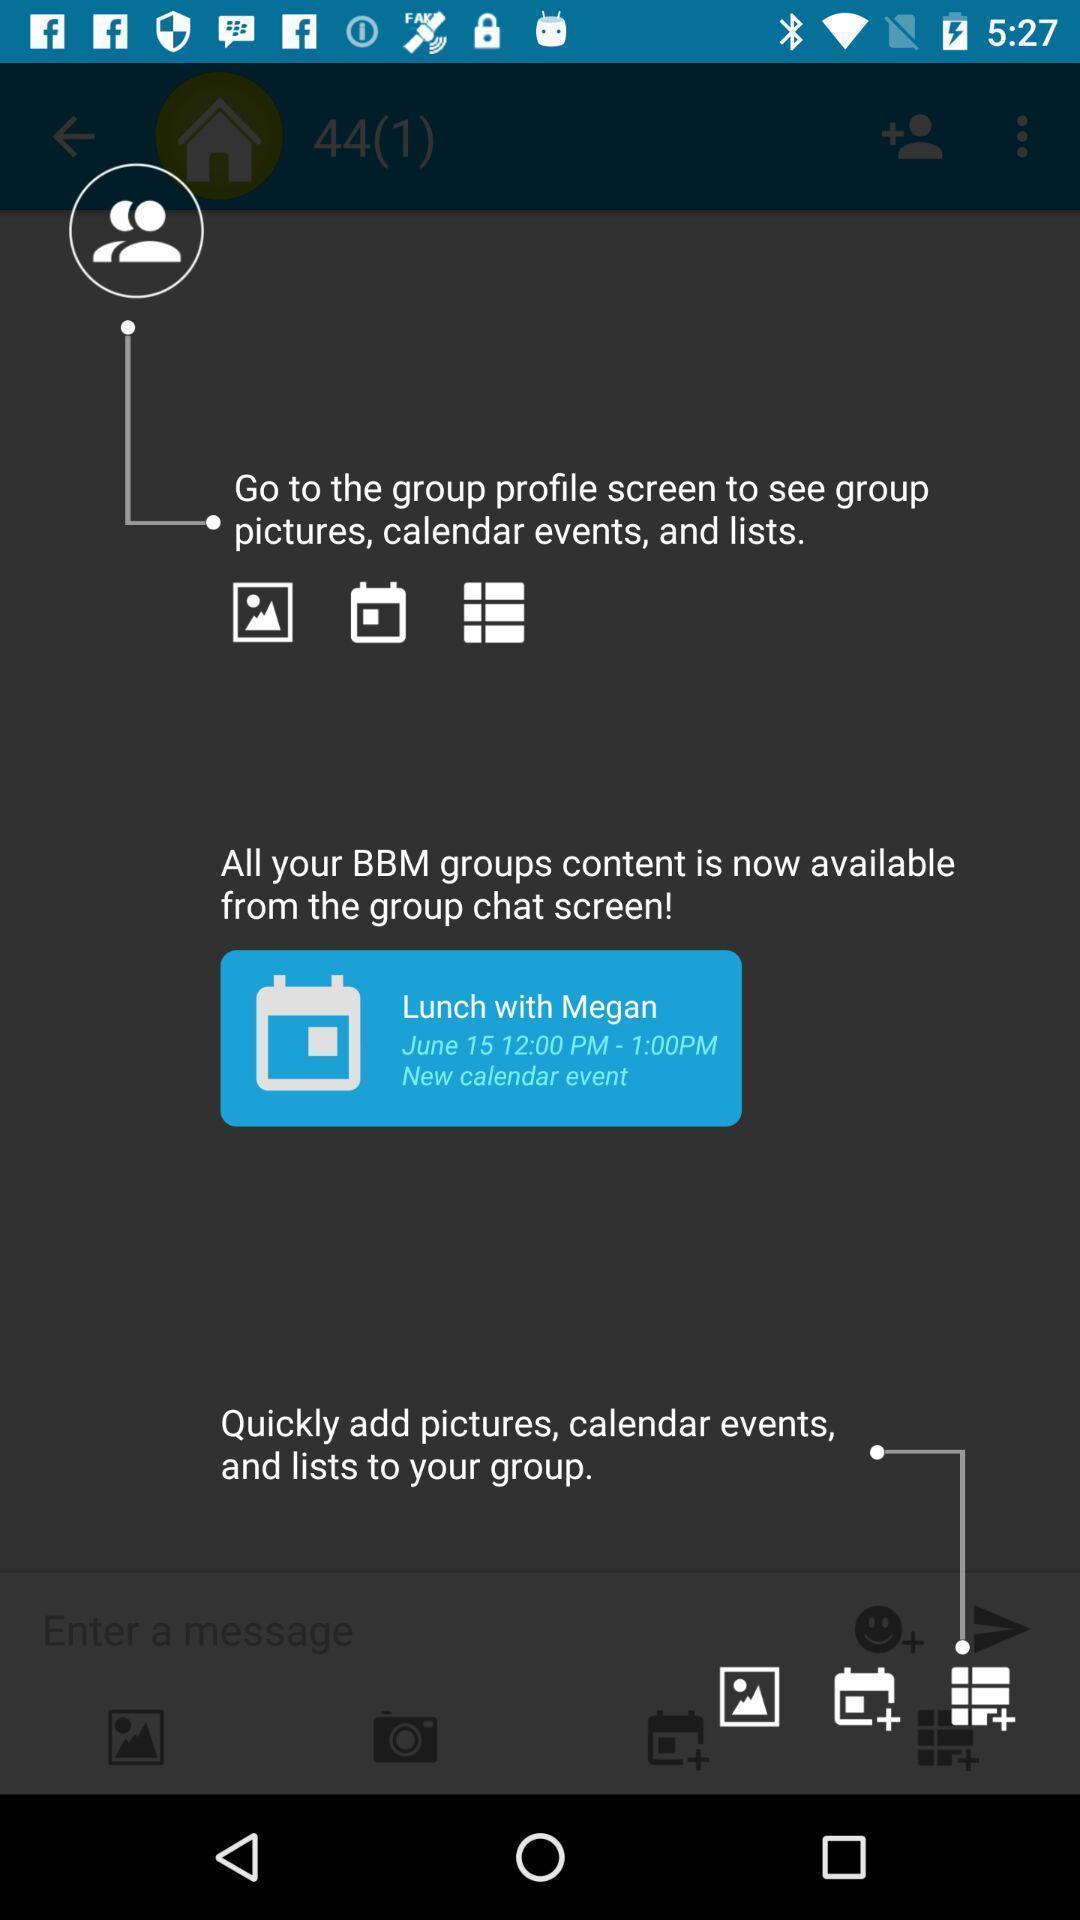What is the overall content of this screenshot? Pop-up shows multiple instructions in a chat app. 